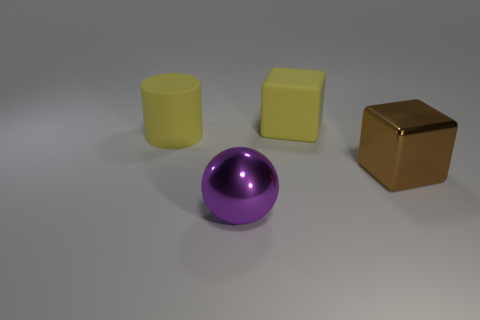There is a object that is the same color as the rubber cylinder; what shape is it?
Make the answer very short. Cube. Do the object left of the shiny sphere and the large rubber object behind the large matte cylinder have the same color?
Offer a terse response. Yes. Are there any rubber blocks of the same size as the cylinder?
Your answer should be compact. Yes. What is the material of the large object that is both on the left side of the large yellow block and to the right of the yellow rubber cylinder?
Offer a very short reply. Metal. What number of metallic things are yellow blocks or big brown objects?
Your answer should be compact. 1. There is a yellow object that is made of the same material as the large yellow cube; what is its shape?
Offer a terse response. Cylinder. How many things are to the right of the rubber cube and left of the large purple thing?
Make the answer very short. 0. Are there any other things that have the same shape as the big purple thing?
Your answer should be very brief. No. What size is the yellow thing behind the cylinder?
Keep it short and to the point. Large. How many other objects are there of the same color as the big cylinder?
Provide a succinct answer. 1. 